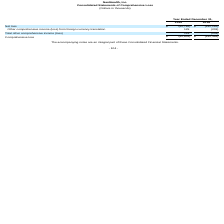From Nanthealth's financial document, What are the respective net losses made by the company in 2018 and 2019? The document shows two values: 192,152 and 62,762 (in thousands). From the document: "Net loss $ (62,762) $ (192,152) Net loss $ (62,762) $ (192,152)..." Also, What are the respective comprehensive losses made by the company in 2018 and 2019? The document shows two values: 192,355 and 62,633 (in thousands). From the document: "Comprehensive loss $ (62,633) $ (192,355) Comprehensive loss $ (62,633) $ (192,355)..." Also, What is the total other comprehensive loss made by the company in 2018? According to the financial document, 203 (in thousands). The relevant text states: "ome (loss) from foreign currency translation 129 (203)..." Also, can you calculate: What is the average net loss in 2018 and 2019? To answer this question, I need to perform calculations using the financial data. The calculation is: (192,152 + 62,762)/2 , which equals 127457 (in thousands). This is based on the information: "Net loss $ (62,762) $ (192,152) Net loss $ (62,762) $ (192,152)..." The key data points involved are: 192,152, 62,762. Also, can you calculate: What is the percentage change in net loss between 2018 and 2019? To answer this question, I need to perform calculations using the financial data. The calculation is: (62,762 - 192,152)/192,152 , which equals -67.34 (percentage). This is based on the information: "Net loss $ (62,762) $ (192,152) Net loss $ (62,762) $ (192,152)..." The key data points involved are: 192,152, 62,762. Also, can you calculate: What is the percentage change in comprehensive loss between 2018 and 2019? To answer this question, I need to perform calculations using the financial data. The calculation is: (62,633 - 192,355)/192,355 , which equals -67.44 (percentage). This is based on the information: "Comprehensive loss $ (62,633) $ (192,355) Comprehensive loss $ (62,633) $ (192,355)..." The key data points involved are: 192,355, 62,633. 